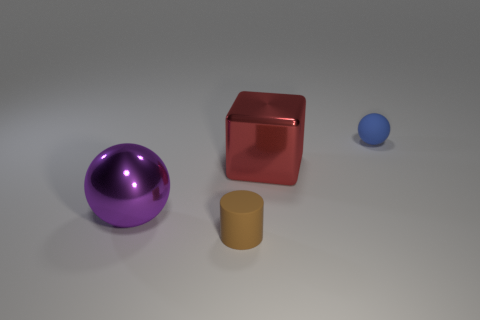Add 1 gray cylinders. How many objects exist? 5 Subtract all blocks. How many objects are left? 3 Add 1 purple shiny spheres. How many purple shiny spheres are left? 2 Add 1 purple balls. How many purple balls exist? 2 Subtract 0 cyan blocks. How many objects are left? 4 Subtract all small yellow metallic things. Subtract all small brown cylinders. How many objects are left? 3 